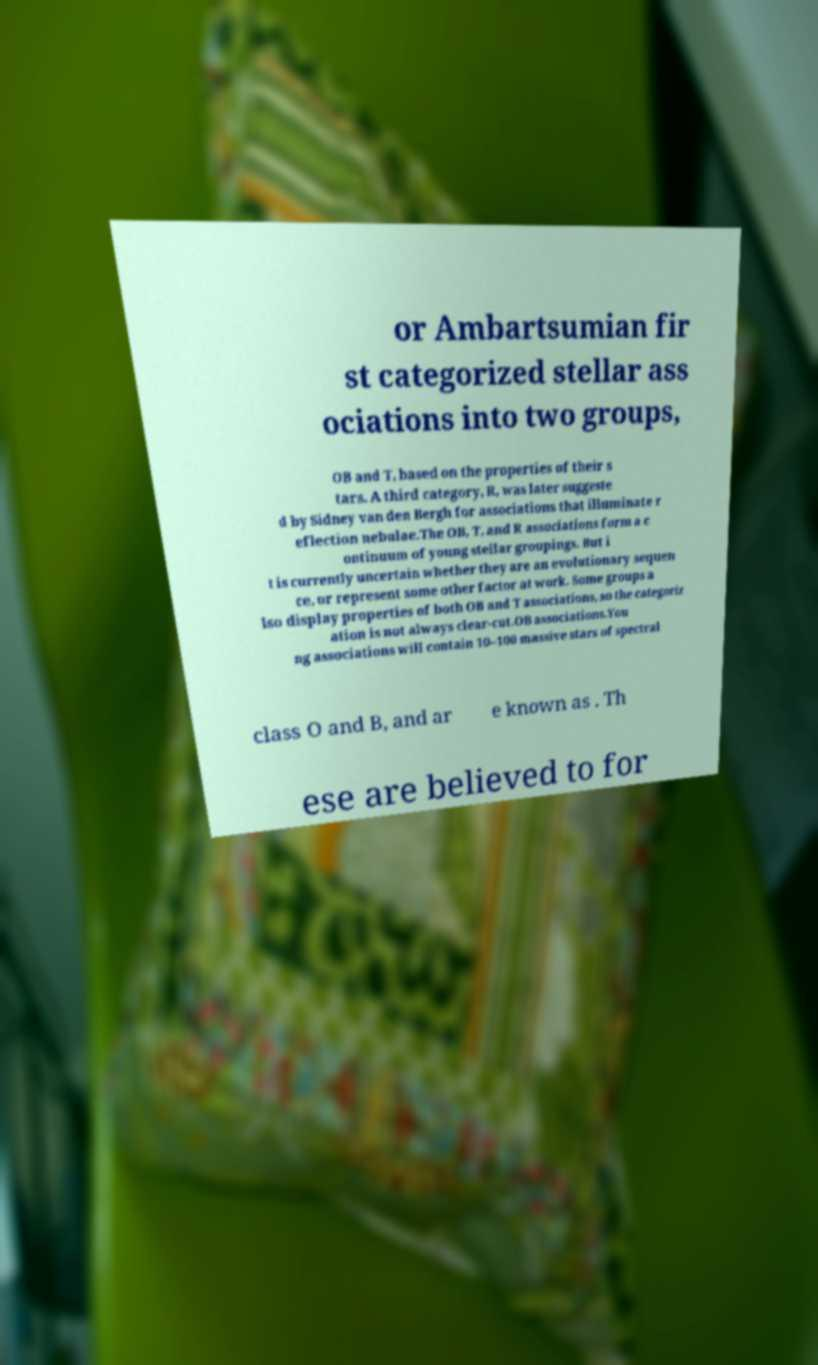What messages or text are displayed in this image? I need them in a readable, typed format. or Ambartsumian fir st categorized stellar ass ociations into two groups, OB and T, based on the properties of their s tars. A third category, R, was later suggeste d by Sidney van den Bergh for associations that illuminate r eflection nebulae.The OB, T, and R associations form a c ontinuum of young stellar groupings. But i t is currently uncertain whether they are an evolutionary sequen ce, or represent some other factor at work. Some groups a lso display properties of both OB and T associations, so the categoriz ation is not always clear-cut.OB associations.You ng associations will contain 10–100 massive stars of spectral class O and B, and ar e known as . Th ese are believed to for 